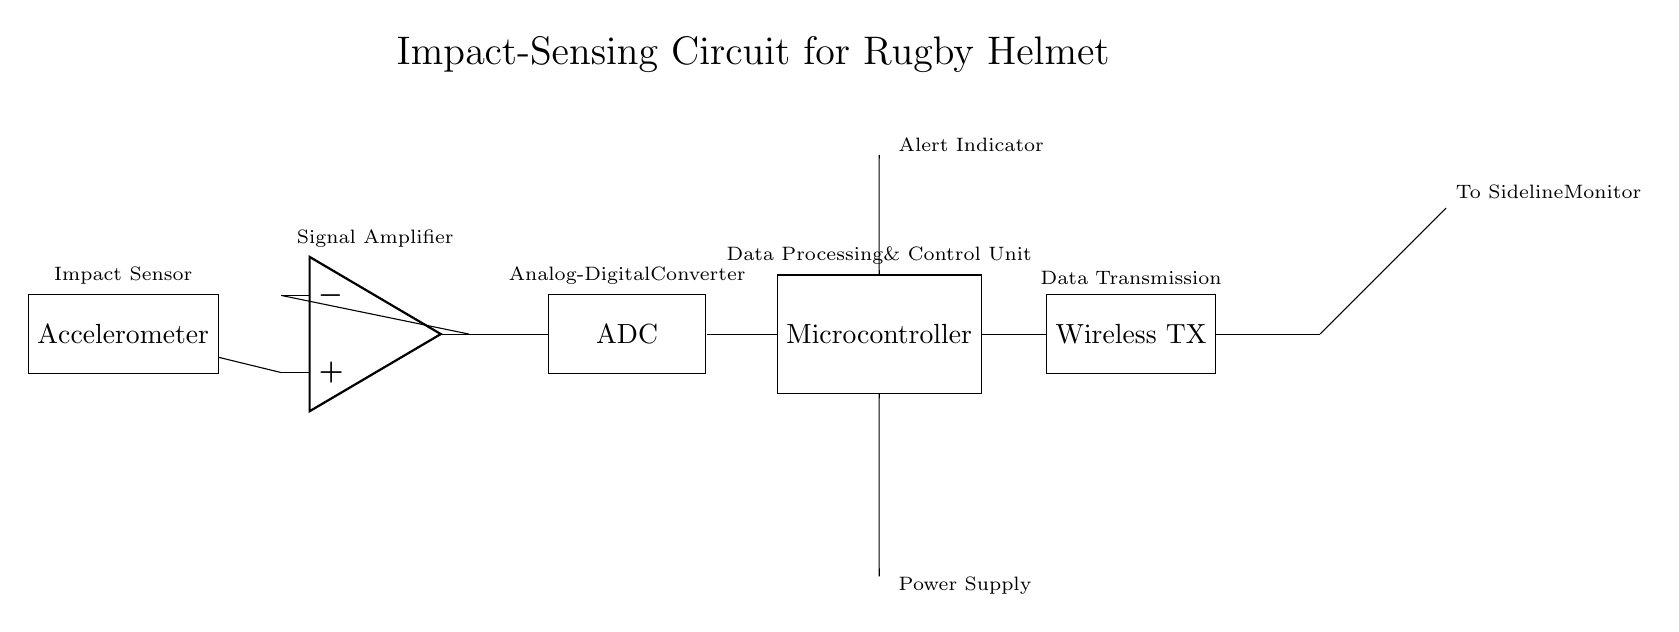What is the primary function of the accelerometer in this circuit? The accelerometer's primary function is to detect impacts by measuring acceleration forces, which is critical for concussion detection.
Answer: Detect impacts What component amplifies the signal from the accelerometer? The operational amplifier (op amp) is the component that amplifies the signal received from the accelerometer, enhancing its importance for further processing.
Answer: Operational amplifier Which component processes the digitized signal? The microcontroller is responsible for processing the digitized signal after it has been converted by the ADC, allowing for appropriate responses like alerts or data transmission.
Answer: Microcontroller What is the purpose of the wireless transmitter in this circuit? The wireless transmitter is used to send data to the sideline monitor, allowing real-time analysis of impacts detected by the helmet.
Answer: Data transmission How does the LED indicator function in this circuit? The LED indicator serves as an alert system that visually signals when an impact has been detected and processed by the microcontroller, enhancing player safety.
Answer: Alert indicator What is the role of the ADC in this circuit? The ADC converts the analog signal amplified by the op amp into a digital signal for the microcontroller to process, bridging the gap between the analog and digital domains.
Answer: Analog-Digital Converter 